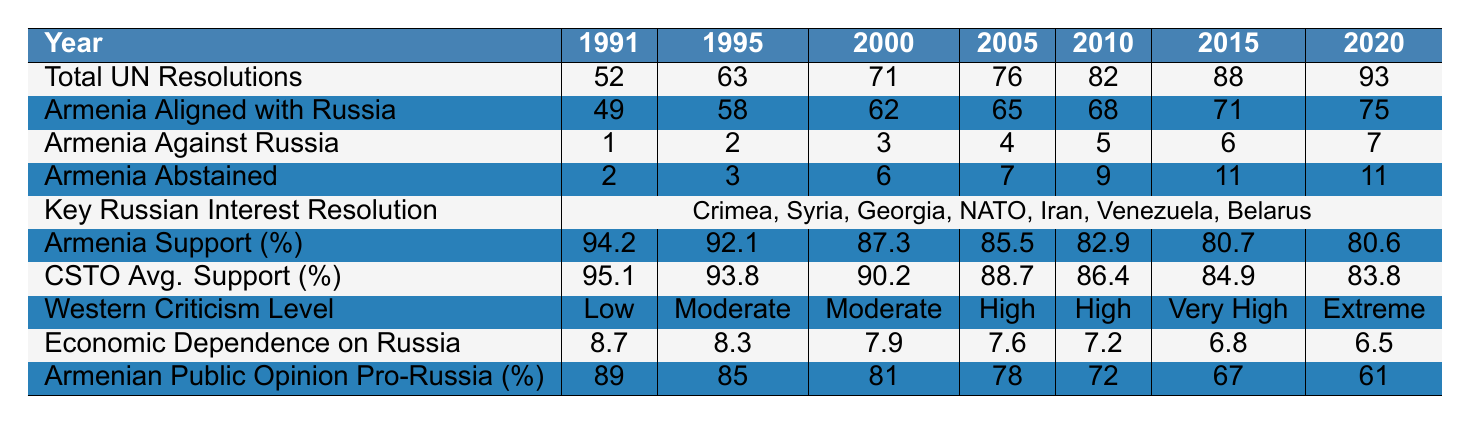What was the highest percentage of Armenia's support for Russia in UN resolutions? The highest percentage of Armenia's support for Russia is found in the year 1991, which is 94.2%.
Answer: 94.2% How many resolutions did Armenia align with Russia in 2020? In 2020, Armenia aligned with Russia in 75 out of 93 total UN resolutions.
Answer: 75 What is the trend in Armenia's economic dependence on Russia from 1991 to 2020? The economic dependence on Russia decreased from 8.7 in 1991 to 6.5 in 2020.
Answer: Decreased What is the average level of Western criticism from 1991 to 2020? The level of Western criticism changes from "Low" in 1991 to "Extreme" in 2020, which indicates a trend of increasing criticism; the average is from the descriptors provided.
Answer: Increasing What was the total number of resolutions Armenia abstained from in 2015? In 2015, Armenia abstained from 11 resolutions according to the table.
Answer: 11 What percentage of Armenian public opinion was pro-Russia in 2015? In 2015, the percentage of Armenian public opinion that was pro-Russia was 67%.
Answer: 67% How does the Armenian support percentage in 2010 compare to the CSTO average support percentage in the same year? In 2010, Armenia's support percentage was 82.9% while the CSTO average support percentage was 86.4%. The CSTO support was higher by 3.5%.
Answer: CSTO support was higher by 3.5% How many resolutions did Armenia vote against Russia from 1991 to 2020? Summing the votes against Russia for each year from the data gives a total of 28 (1+2+3+4+5+6+7).
Answer: 28 Was there an increase in the number of total UN resolutions from 2010 to 2015? Yes, from 2010 (82 resolutions) to 2015 (88 resolutions), there was an increase of 6 resolutions.
Answer: Yes What correlation can be observed between the Armenian public opinion pro-Russia and the Western criticism level from 1991 to 2020? As the public opinion percentage decreases from 89% to 61%, the level of Western criticism increases from "Low" to "Extreme," suggesting a possible correlation.
Answer: Negative correlation 